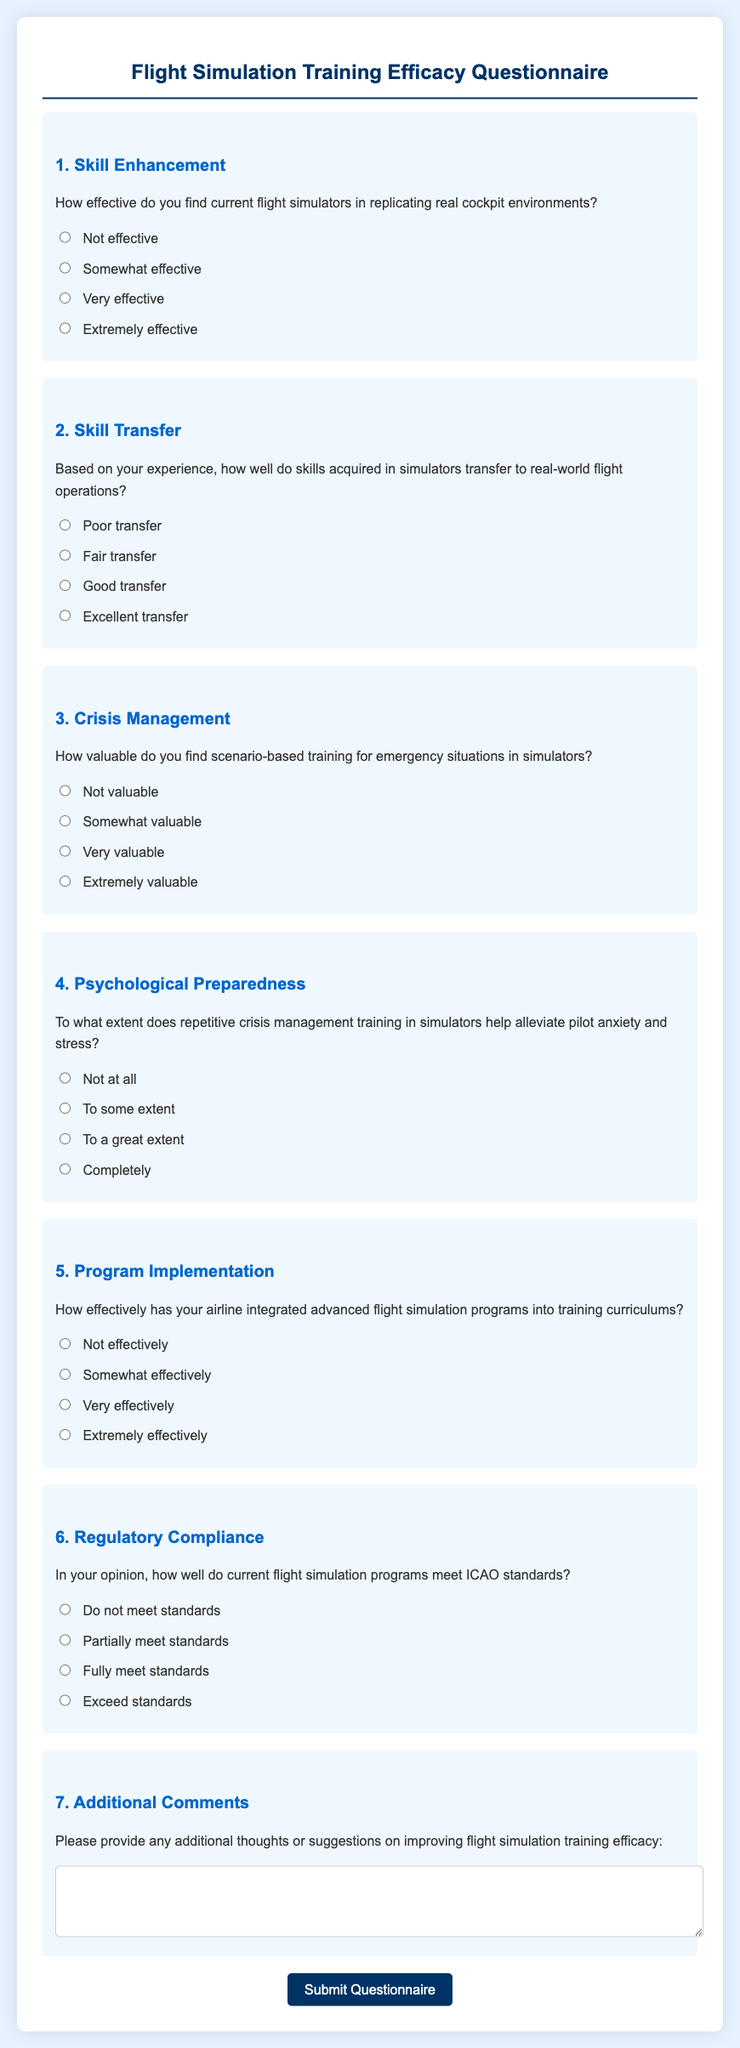What is the title of the questionnaire? The title of the questionnaire is mentioned at the top of the document.
Answer: Flight Simulation Training Efficacy Questionnaire How many main questions are included in the questionnaire? There are seven main questions listed in the questionnaire.
Answer: 7 What is the highest rating for simulator effectiveness? The ratings for simulator effectiveness are indicated in the options provided.
Answer: Extremely effective What topic does Question 3 focus on? Question 3 specifically addresses the value of training for emergency situations.
Answer: Crisis Management What type of feedback is requested in the last question? The last question invites additional feedback or suggestions related to the training.
Answer: Additional Comments How does the questionnaire ask participants to evaluate their airline's simulation program integration? The questionnaire includes a specific question about the effectiveness of integration into training curriculums.
Answer: Effectively Which standards are referenced in Question 6? The standards mentioned in Question 6 relate to international aviation regulations.
Answer: ICAO standards What background color is used for the questionnaire container? The container's background color is defined in the styling of the document.
Answer: White 